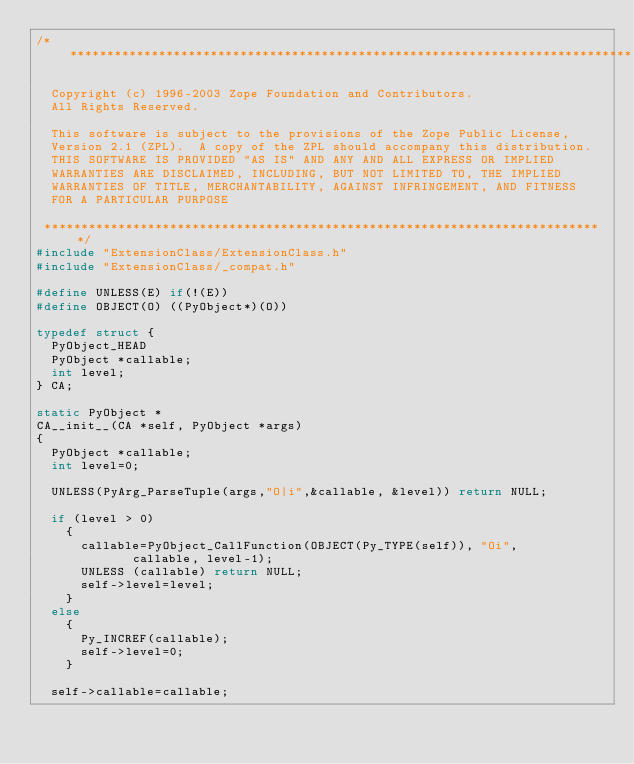<code> <loc_0><loc_0><loc_500><loc_500><_C_>/*****************************************************************************

  Copyright (c) 1996-2003 Zope Foundation and Contributors.
  All Rights Reserved.

  This software is subject to the provisions of the Zope Public License,
  Version 2.1 (ZPL).  A copy of the ZPL should accompany this distribution.
  THIS SOFTWARE IS PROVIDED "AS IS" AND ANY AND ALL EXPRESS OR IMPLIED
  WARRANTIES ARE DISCLAIMED, INCLUDING, BUT NOT LIMITED TO, THE IMPLIED
  WARRANTIES OF TITLE, MERCHANTABILITY, AGAINST INFRINGEMENT, AND FITNESS
  FOR A PARTICULAR PURPOSE

 ****************************************************************************/
#include "ExtensionClass/ExtensionClass.h"
#include "ExtensionClass/_compat.h"

#define UNLESS(E) if(!(E))
#define OBJECT(O) ((PyObject*)(O))

typedef struct {
  PyObject_HEAD
  PyObject *callable;
  int level;
} CA;

static PyObject *
CA__init__(CA *self, PyObject *args)
{
  PyObject *callable;
  int level=0;

  UNLESS(PyArg_ParseTuple(args,"O|i",&callable, &level)) return NULL;

  if (level > 0) 
    {
      callable=PyObject_CallFunction(OBJECT(Py_TYPE(self)), "Oi", 
				     callable, level-1);
      UNLESS (callable) return NULL;
      self->level=level;
    }
  else
    {
      Py_INCREF(callable);
      self->level=0;
    }

  self->callable=callable;
</code> 